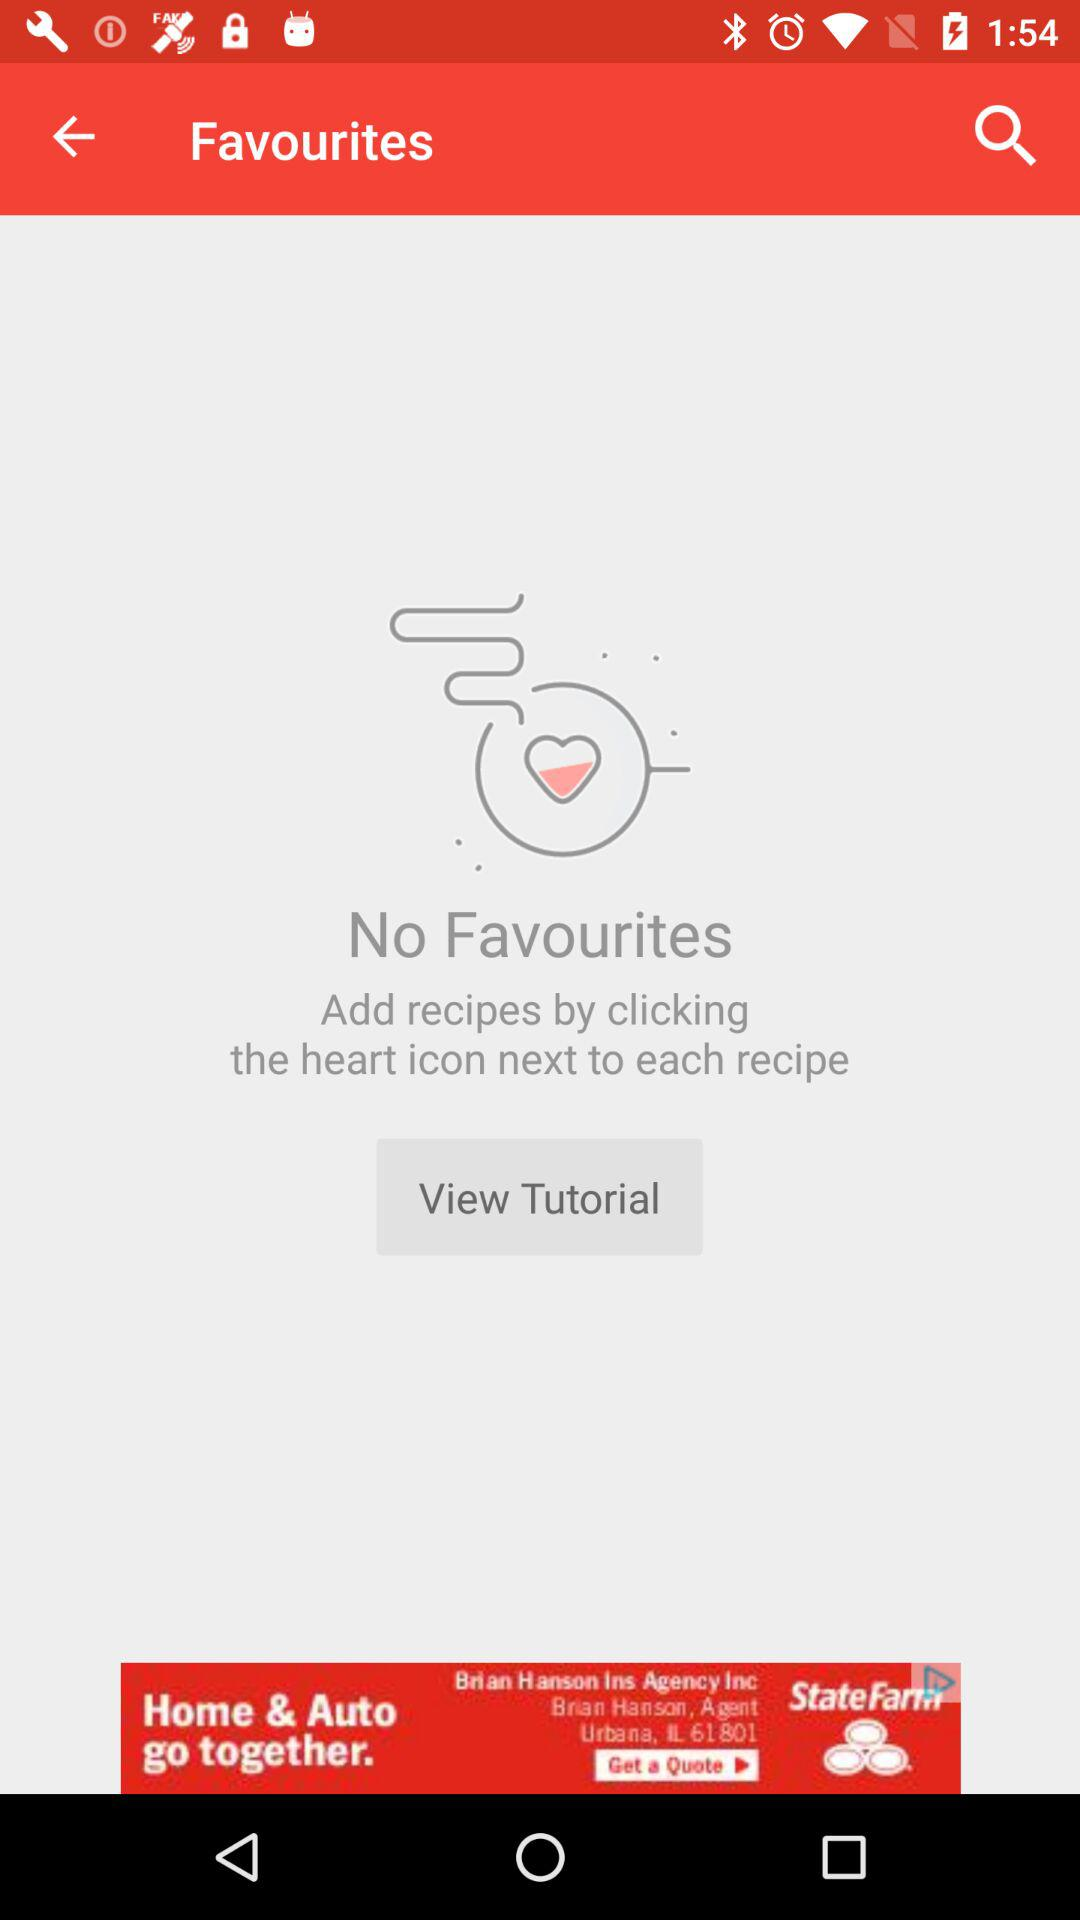Are there any favorites shown on the screen? There are no favorites shown on the screen. 